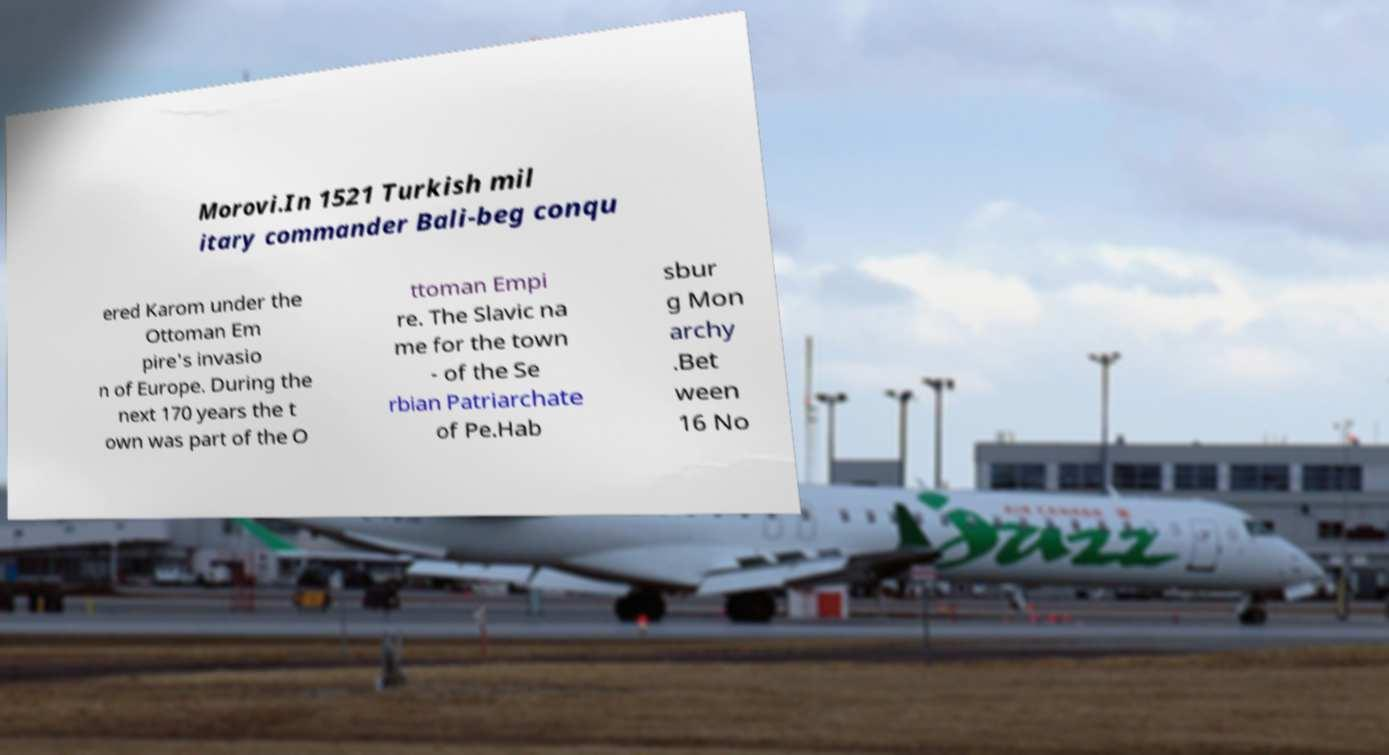Could you assist in decoding the text presented in this image and type it out clearly? Morovi.In 1521 Turkish mil itary commander Bali-beg conqu ered Karom under the Ottoman Em pire's invasio n of Europe. During the next 170 years the t own was part of the O ttoman Empi re. The Slavic na me for the town - of the Se rbian Patriarchate of Pe.Hab sbur g Mon archy .Bet ween 16 No 